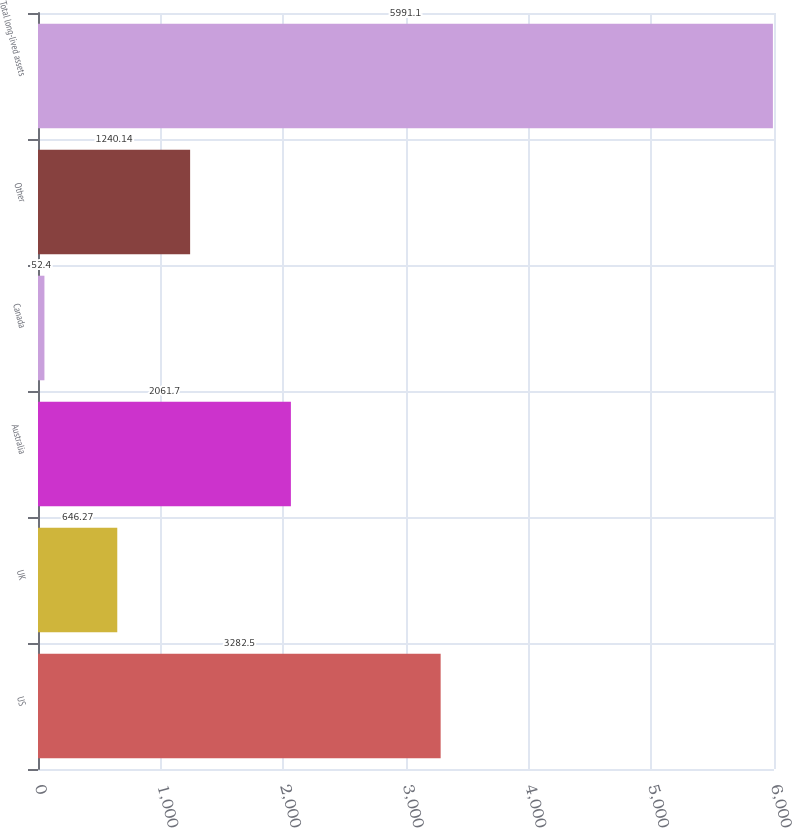<chart> <loc_0><loc_0><loc_500><loc_500><bar_chart><fcel>US<fcel>UK<fcel>Australia<fcel>Canada<fcel>Other<fcel>Total long-lived assets<nl><fcel>3282.5<fcel>646.27<fcel>2061.7<fcel>52.4<fcel>1240.14<fcel>5991.1<nl></chart> 